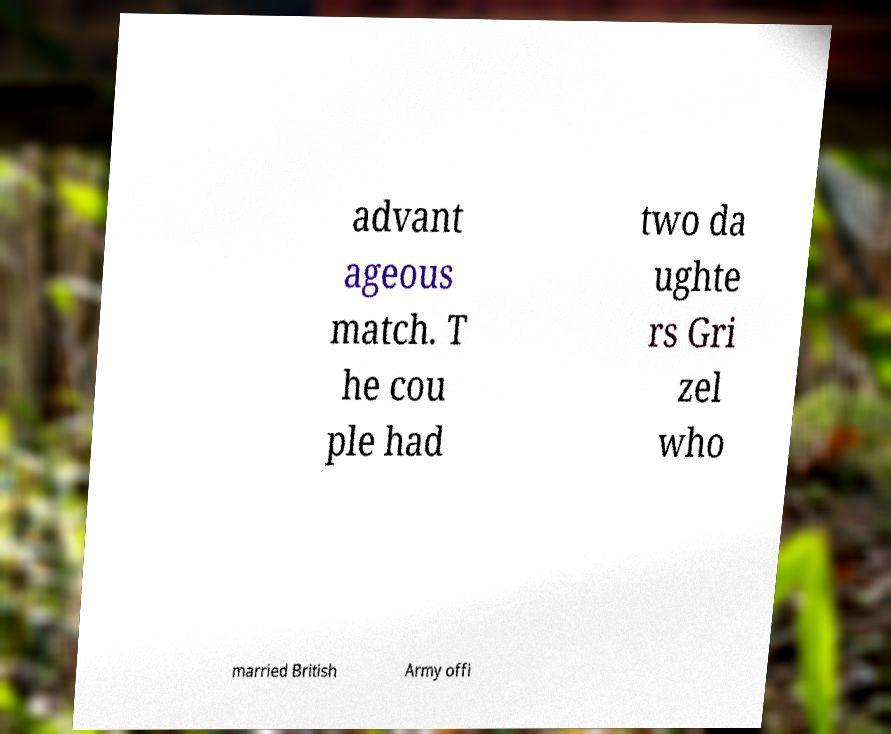Can you read and provide the text displayed in the image?This photo seems to have some interesting text. Can you extract and type it out for me? advant ageous match. T he cou ple had two da ughte rs Gri zel who married British Army offi 